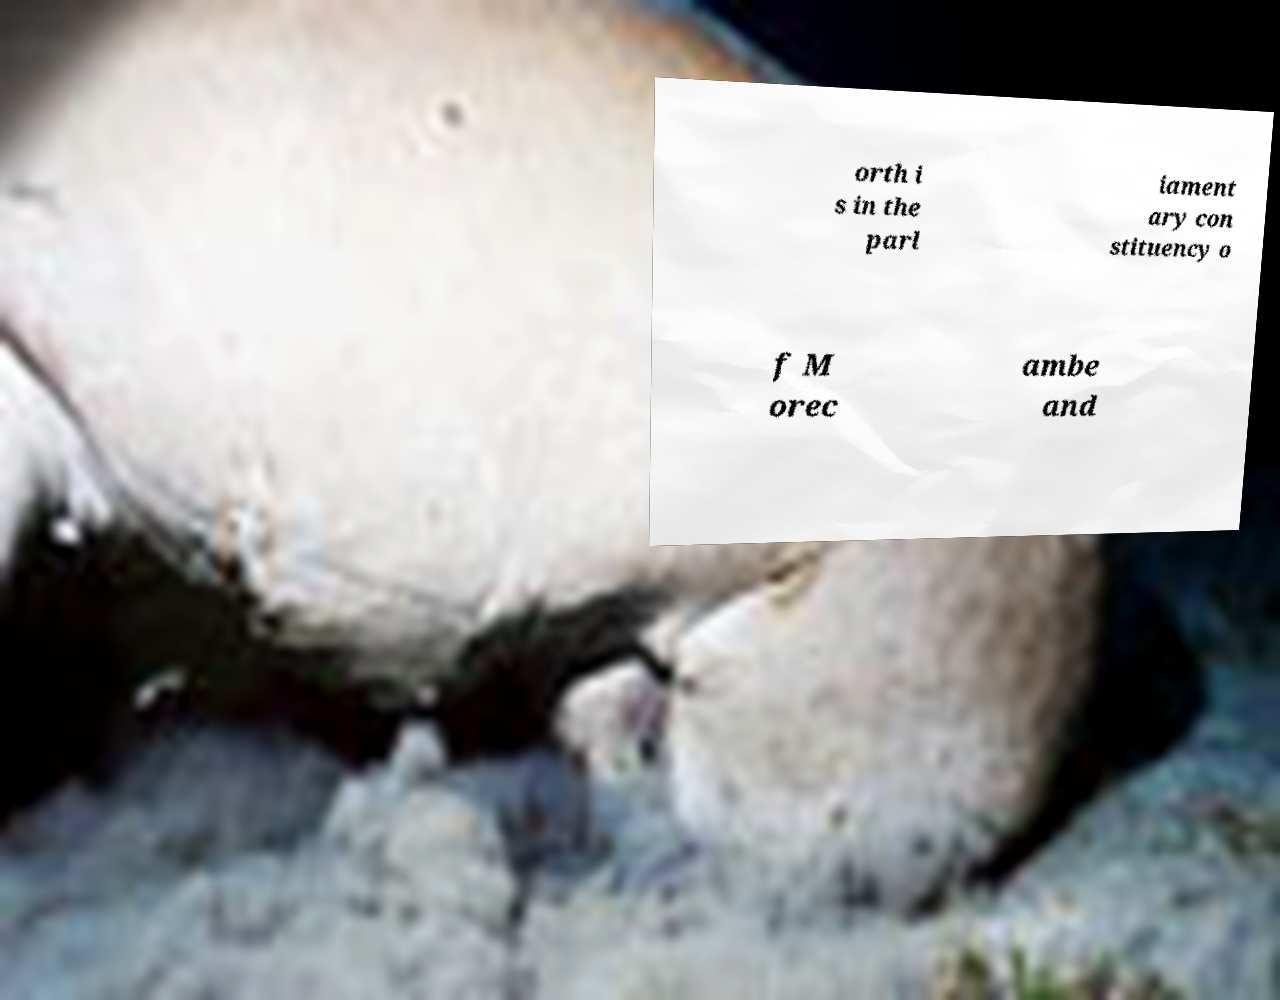Please identify and transcribe the text found in this image. orth i s in the parl iament ary con stituency o f M orec ambe and 